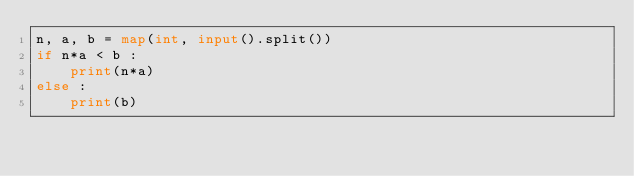<code> <loc_0><loc_0><loc_500><loc_500><_Python_>n, a, b = map(int, input().split())
if n*a < b :
    print(n*a)
else :
    print(b)</code> 